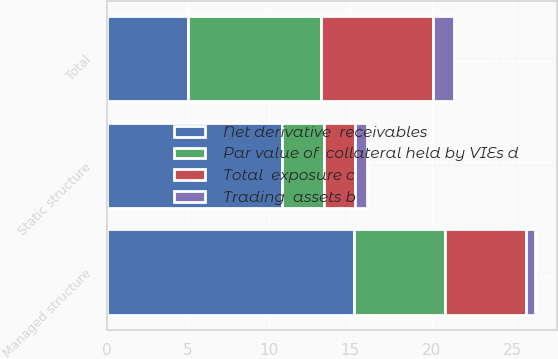Convert chart. <chart><loc_0><loc_0><loc_500><loc_500><stacked_bar_chart><ecel><fcel>Static structure<fcel>Managed structure<fcel>Total<nl><fcel>Total  exposure c<fcel>1.9<fcel>5<fcel>6.9<nl><fcel>Trading  assets b<fcel>0.7<fcel>0.6<fcel>1.3<nl><fcel>Par value of  collateral held by VIEs d<fcel>2.6<fcel>5.6<fcel>8.2<nl><fcel>Net derivative  receivables<fcel>10.8<fcel>15.2<fcel>5<nl></chart> 